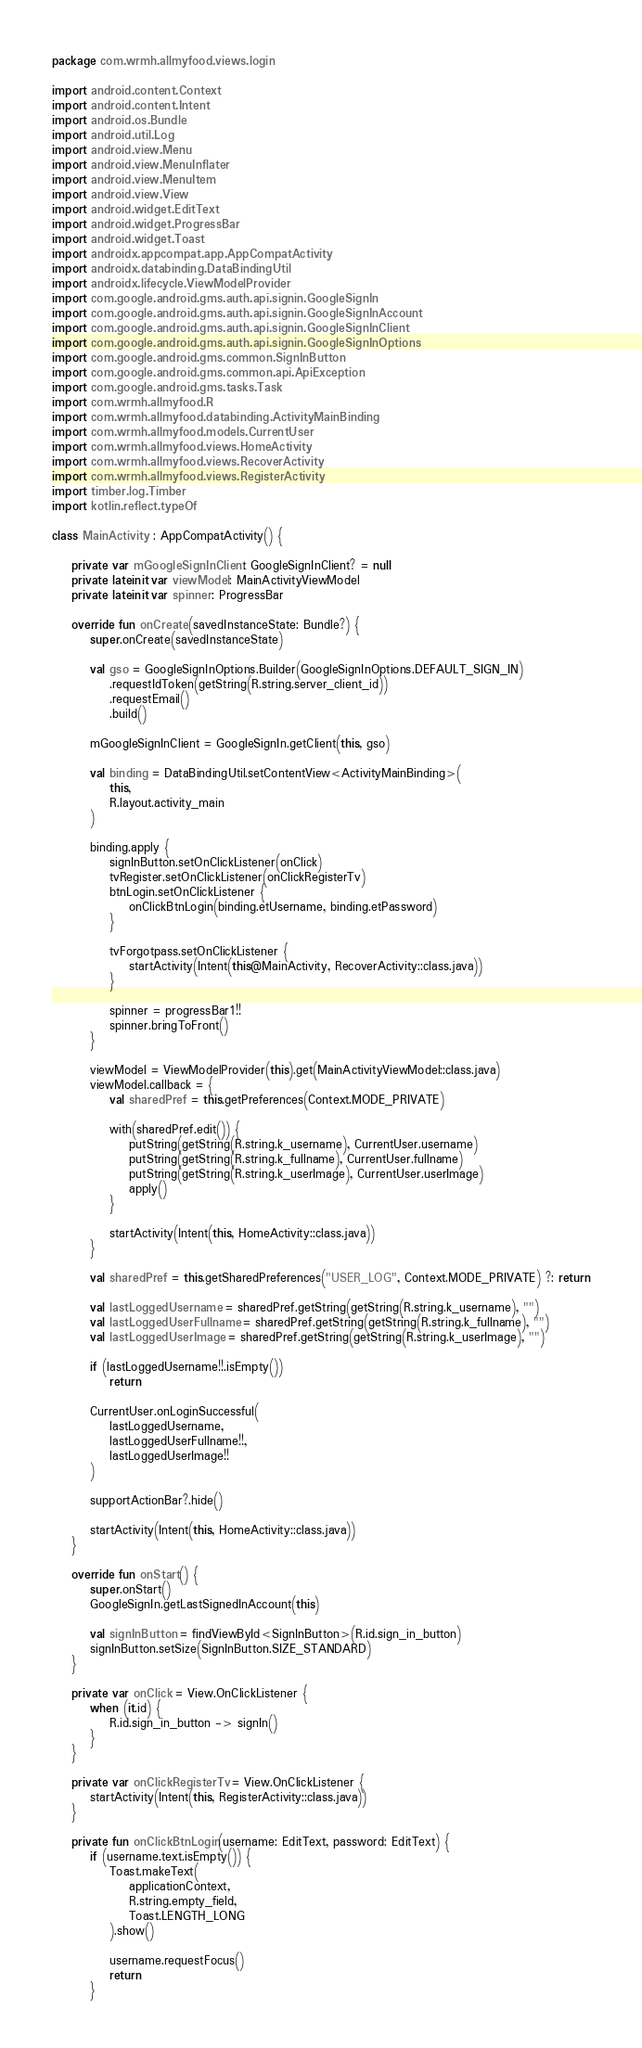Convert code to text. <code><loc_0><loc_0><loc_500><loc_500><_Kotlin_>package com.wrmh.allmyfood.views.login

import android.content.Context
import android.content.Intent
import android.os.Bundle
import android.util.Log
import android.view.Menu
import android.view.MenuInflater
import android.view.MenuItem
import android.view.View
import android.widget.EditText
import android.widget.ProgressBar
import android.widget.Toast
import androidx.appcompat.app.AppCompatActivity
import androidx.databinding.DataBindingUtil
import androidx.lifecycle.ViewModelProvider
import com.google.android.gms.auth.api.signin.GoogleSignIn
import com.google.android.gms.auth.api.signin.GoogleSignInAccount
import com.google.android.gms.auth.api.signin.GoogleSignInClient
import com.google.android.gms.auth.api.signin.GoogleSignInOptions
import com.google.android.gms.common.SignInButton
import com.google.android.gms.common.api.ApiException
import com.google.android.gms.tasks.Task
import com.wrmh.allmyfood.R
import com.wrmh.allmyfood.databinding.ActivityMainBinding
import com.wrmh.allmyfood.models.CurrentUser
import com.wrmh.allmyfood.views.HomeActivity
import com.wrmh.allmyfood.views.RecoverActivity
import com.wrmh.allmyfood.views.RegisterActivity
import timber.log.Timber
import kotlin.reflect.typeOf

class MainActivity : AppCompatActivity() {

    private var mGoogleSignInClient: GoogleSignInClient? = null
    private lateinit var viewModel: MainActivityViewModel
    private lateinit var spinner: ProgressBar

    override fun onCreate(savedInstanceState: Bundle?) {
        super.onCreate(savedInstanceState)

        val gso = GoogleSignInOptions.Builder(GoogleSignInOptions.DEFAULT_SIGN_IN)
            .requestIdToken(getString(R.string.server_client_id))
            .requestEmail()
            .build()

        mGoogleSignInClient = GoogleSignIn.getClient(this, gso)

        val binding = DataBindingUtil.setContentView<ActivityMainBinding>(
            this,
            R.layout.activity_main
        )

        binding.apply {
            signInButton.setOnClickListener(onClick)
            tvRegister.setOnClickListener(onClickRegisterTv)
            btnLogin.setOnClickListener {
                onClickBtnLogin(binding.etUsername, binding.etPassword)
            }

            tvForgotpass.setOnClickListener {
                startActivity(Intent(this@MainActivity, RecoverActivity::class.java))
            }

            spinner = progressBar1!!
            spinner.bringToFront()
        }

        viewModel = ViewModelProvider(this).get(MainActivityViewModel::class.java)
        viewModel.callback = {
            val sharedPref = this.getPreferences(Context.MODE_PRIVATE)

            with(sharedPref.edit()) {
                putString(getString(R.string.k_username), CurrentUser.username)
                putString(getString(R.string.k_fullname), CurrentUser.fullname)
                putString(getString(R.string.k_userImage), CurrentUser.userImage)
                apply()
            }

            startActivity(Intent(this, HomeActivity::class.java))
        }

        val sharedPref = this.getSharedPreferences("USER_LOG", Context.MODE_PRIVATE) ?: return

        val lastLoggedUsername = sharedPref.getString(getString(R.string.k_username), "")
        val lastLoggedUserFullname = sharedPref.getString(getString(R.string.k_fullname), "")
        val lastLoggedUserImage = sharedPref.getString(getString(R.string.k_userImage), "")

        if (lastLoggedUsername!!.isEmpty())
            return

        CurrentUser.onLoginSuccessful(
            lastLoggedUsername,
            lastLoggedUserFullname!!,
            lastLoggedUserImage!!
        )

        supportActionBar?.hide()

        startActivity(Intent(this, HomeActivity::class.java))
    }

    override fun onStart() {
        super.onStart()
        GoogleSignIn.getLastSignedInAccount(this)

        val signInButton = findViewById<SignInButton>(R.id.sign_in_button)
        signInButton.setSize(SignInButton.SIZE_STANDARD)
    }

    private var onClick = View.OnClickListener {
        when (it.id) {
            R.id.sign_in_button -> signIn()
        }
    }

    private var onClickRegisterTv = View.OnClickListener {
        startActivity(Intent(this, RegisterActivity::class.java))
    }

    private fun onClickBtnLogin(username: EditText, password: EditText) {
        if (username.text.isEmpty()) {
            Toast.makeText(
                applicationContext,
                R.string.empty_field,
                Toast.LENGTH_LONG
            ).show()

            username.requestFocus()
            return
        }</code> 